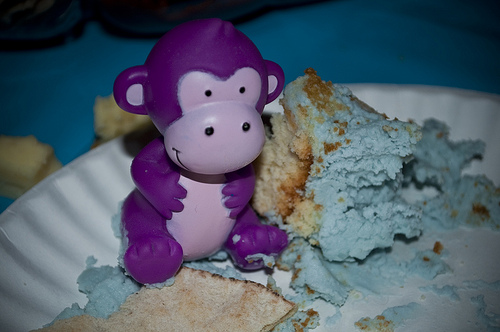<image>
Is the frosting on the monkey? Yes. Looking at the image, I can see the frosting is positioned on top of the monkey, with the monkey providing support. Where is the doll in relation to the plate? Is it on the plate? Yes. Looking at the image, I can see the doll is positioned on top of the plate, with the plate providing support. 